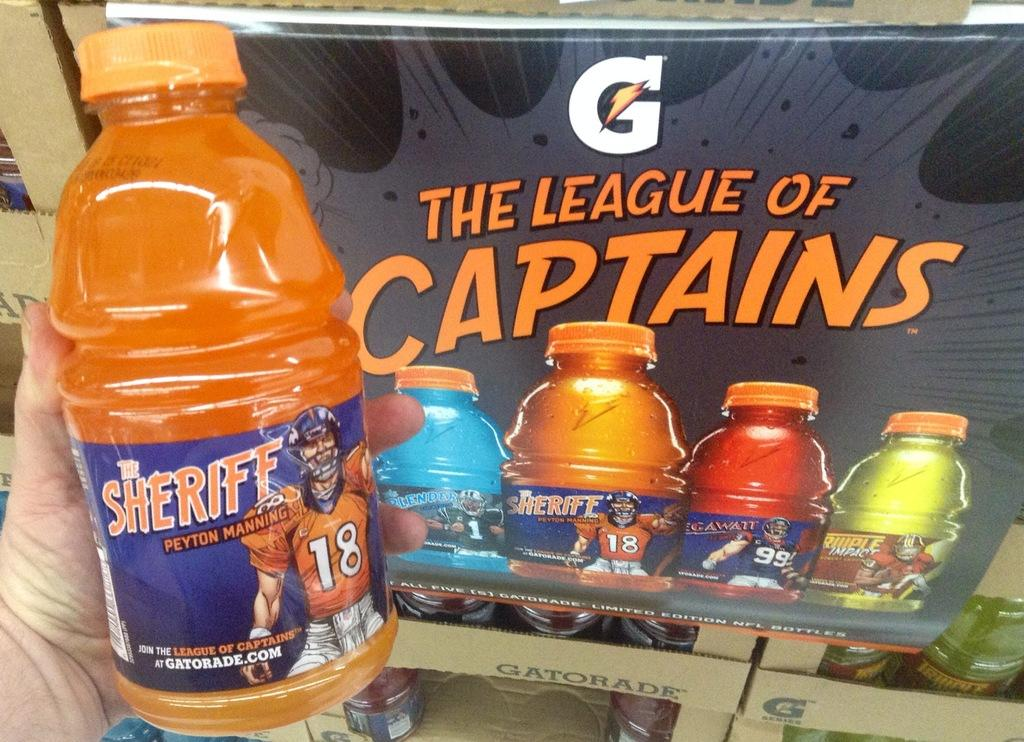<image>
Relay a brief, clear account of the picture shown. A person is holding a Gatorade sports drink in front of a Gatorade advertisement. 